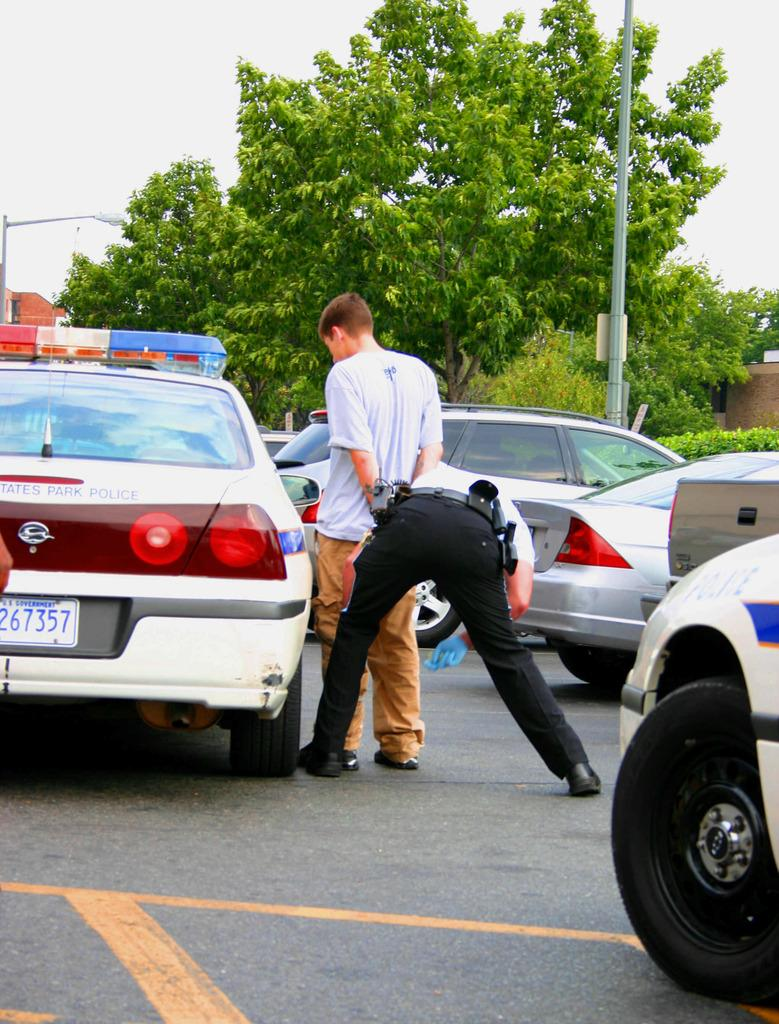How many people are in the image? There are two persons standing in the image. What can be seen on the road in the image? There are cars on the road in the image. What is visible in the background of the image? There is a house, poles, light, trees, and the sky visible in the background of the image. What type of silk fabric is draped over the bat in the image? There is no bat or silk fabric present in the image. What sound can be heard coming from the house in the background of the image? The image is a still picture, so no sounds can be heard. 